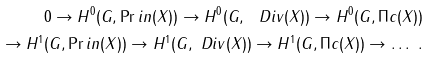<formula> <loc_0><loc_0><loc_500><loc_500>0 \rightarrow H ^ { 0 } ( G , \Pr i n ( X ) ) \rightarrow H ^ { 0 } ( G , \ D i v ( X ) ) \rightarrow H ^ { 0 } ( G , \Pi c ( X ) ) \\ \rightarrow H ^ { 1 } ( G , \Pr i n ( X ) ) \rightarrow H ^ { 1 } ( G , \ D i v ( X ) ) \rightarrow H ^ { 1 } ( G , \Pi c ( X ) ) \rightarrow \dots \ .</formula> 